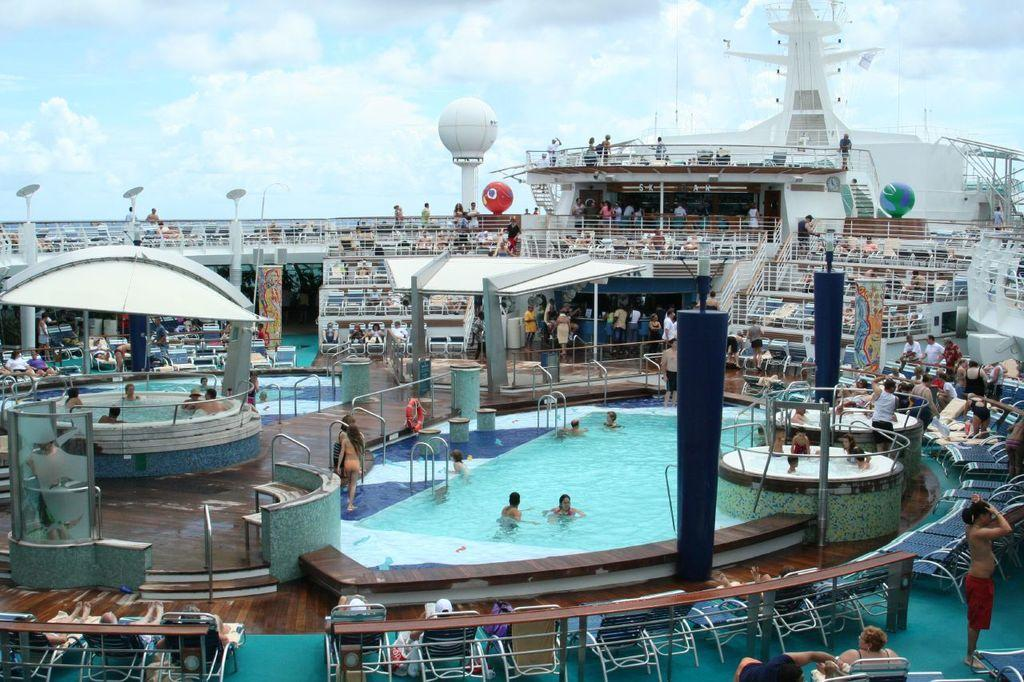Who or what can be seen in the image? There are people in the image. What is the primary element visible in the image? There is water visible in the image. What decorative objects are present in the image? Balloons are present in the image. What is visible at the top of the image? The sky is visible at the top of the image. What type of paste is being used by the people in the image? There is no paste visible or mentioned in the image. 